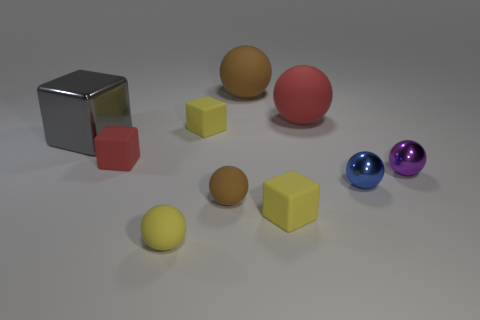Subtract all matte spheres. How many spheres are left? 2 Subtract all yellow spheres. How many yellow cubes are left? 2 Subtract all gray cubes. How many cubes are left? 3 Subtract 2 spheres. How many spheres are left? 4 Subtract all green cubes. Subtract all gray cylinders. How many cubes are left? 4 Subtract all small blue things. Subtract all matte balls. How many objects are left? 5 Add 7 tiny brown rubber spheres. How many tiny brown rubber spheres are left? 8 Add 8 tiny blue objects. How many tiny blue objects exist? 9 Subtract 1 purple balls. How many objects are left? 9 Subtract all cubes. How many objects are left? 6 